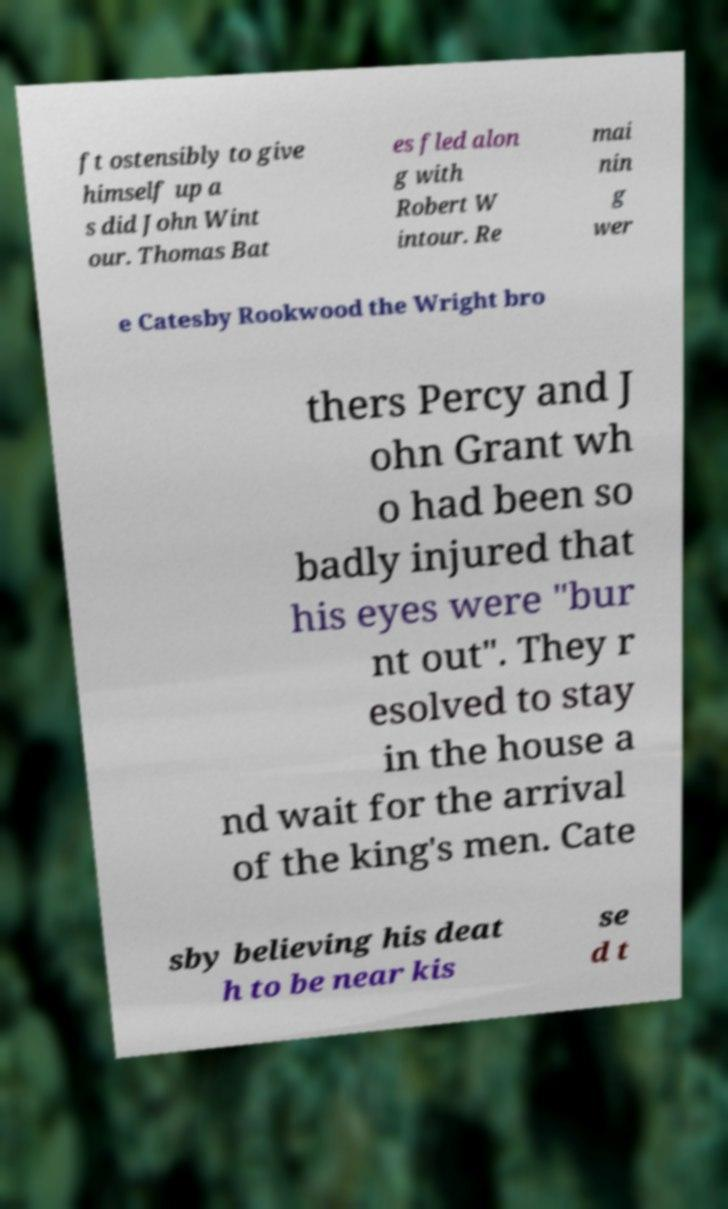Could you extract and type out the text from this image? ft ostensibly to give himself up a s did John Wint our. Thomas Bat es fled alon g with Robert W intour. Re mai nin g wer e Catesby Rookwood the Wright bro thers Percy and J ohn Grant wh o had been so badly injured that his eyes were "bur nt out". They r esolved to stay in the house a nd wait for the arrival of the king's men. Cate sby believing his deat h to be near kis se d t 